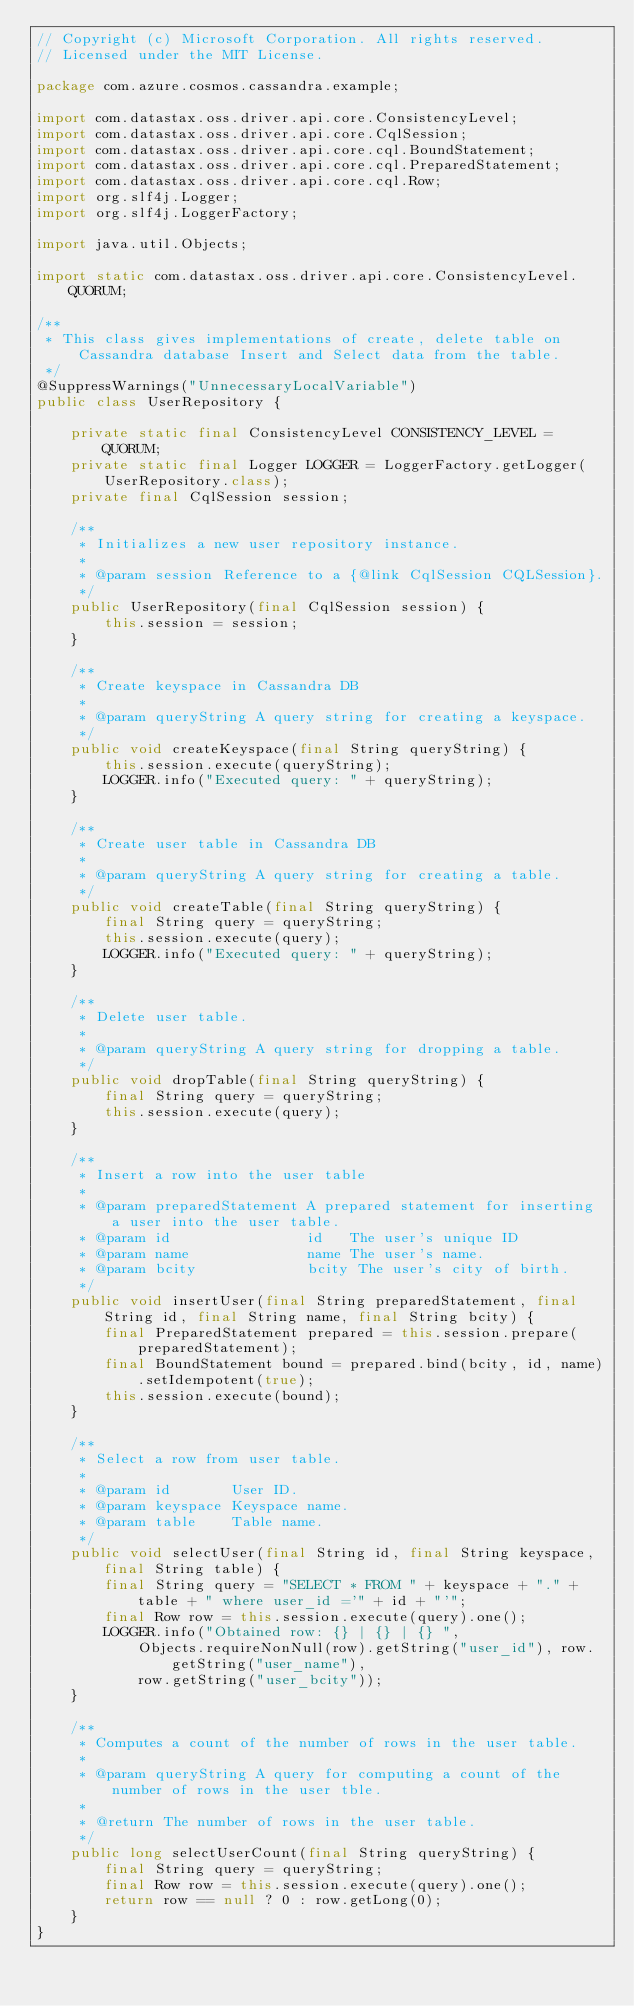<code> <loc_0><loc_0><loc_500><loc_500><_Java_>// Copyright (c) Microsoft Corporation. All rights reserved.
// Licensed under the MIT License.

package com.azure.cosmos.cassandra.example;

import com.datastax.oss.driver.api.core.ConsistencyLevel;
import com.datastax.oss.driver.api.core.CqlSession;
import com.datastax.oss.driver.api.core.cql.BoundStatement;
import com.datastax.oss.driver.api.core.cql.PreparedStatement;
import com.datastax.oss.driver.api.core.cql.Row;
import org.slf4j.Logger;
import org.slf4j.LoggerFactory;

import java.util.Objects;

import static com.datastax.oss.driver.api.core.ConsistencyLevel.QUORUM;

/**
 * This class gives implementations of create, delete table on Cassandra database Insert and Select data from the table.
 */
@SuppressWarnings("UnnecessaryLocalVariable")
public class UserRepository {

    private static final ConsistencyLevel CONSISTENCY_LEVEL = QUORUM;
    private static final Logger LOGGER = LoggerFactory.getLogger(UserRepository.class);
    private final CqlSession session;

    /**
     * Initializes a new user repository instance.
     *
     * @param session Reference to a {@link CqlSession CQLSession}.
     */
    public UserRepository(final CqlSession session) {
        this.session = session;
    }

    /**
     * Create keyspace in Cassandra DB
     *
     * @param queryString A query string for creating a keyspace.
     */
    public void createKeyspace(final String queryString) {
        this.session.execute(queryString);
        LOGGER.info("Executed query: " + queryString);
    }

    /**
     * Create user table in Cassandra DB
     *
     * @param queryString A query string for creating a table.
     */
    public void createTable(final String queryString) {
        final String query = queryString;
        this.session.execute(query);
        LOGGER.info("Executed query: " + queryString);
    }

    /**
     * Delete user table.
     *
     * @param queryString A query string for dropping a table.
     */
    public void dropTable(final String queryString) {
        final String query = queryString;
        this.session.execute(query);
    }

    /**
     * Insert a row into the user table
     *
     * @param preparedStatement A prepared statement for inserting a user into the user table.
     * @param id                id   The user's unique ID
     * @param name              name The user's name.
     * @param bcity             bcity The user's city of birth.
     */
    public void insertUser(final String preparedStatement, final String id, final String name, final String bcity) {
        final PreparedStatement prepared = this.session.prepare(preparedStatement);
        final BoundStatement bound = prepared.bind(bcity, id, name).setIdempotent(true);
        this.session.execute(bound);
    }

    /**
     * Select a row from user table.
     *
     * @param id       User ID.
     * @param keyspace Keyspace name.
     * @param table    Table name.
     */
    public void selectUser(final String id, final String keyspace, final String table) {
        final String query = "SELECT * FROM " + keyspace + "." + table + " where user_id ='" + id + "'";
        final Row row = this.session.execute(query).one();
        LOGGER.info("Obtained row: {} | {} | {} ",
            Objects.requireNonNull(row).getString("user_id"), row.getString("user_name"),
            row.getString("user_bcity"));
    }

    /**
     * Computes a count of the number of rows in the user table.
     *
     * @param queryString A query for computing a count of the number of rows in the user tble.
     *
     * @return The number of rows in the user table.
     */
    public long selectUserCount(final String queryString) {
        final String query = queryString;
        final Row row = this.session.execute(query).one();
        return row == null ? 0 : row.getLong(0);
    }
}
</code> 